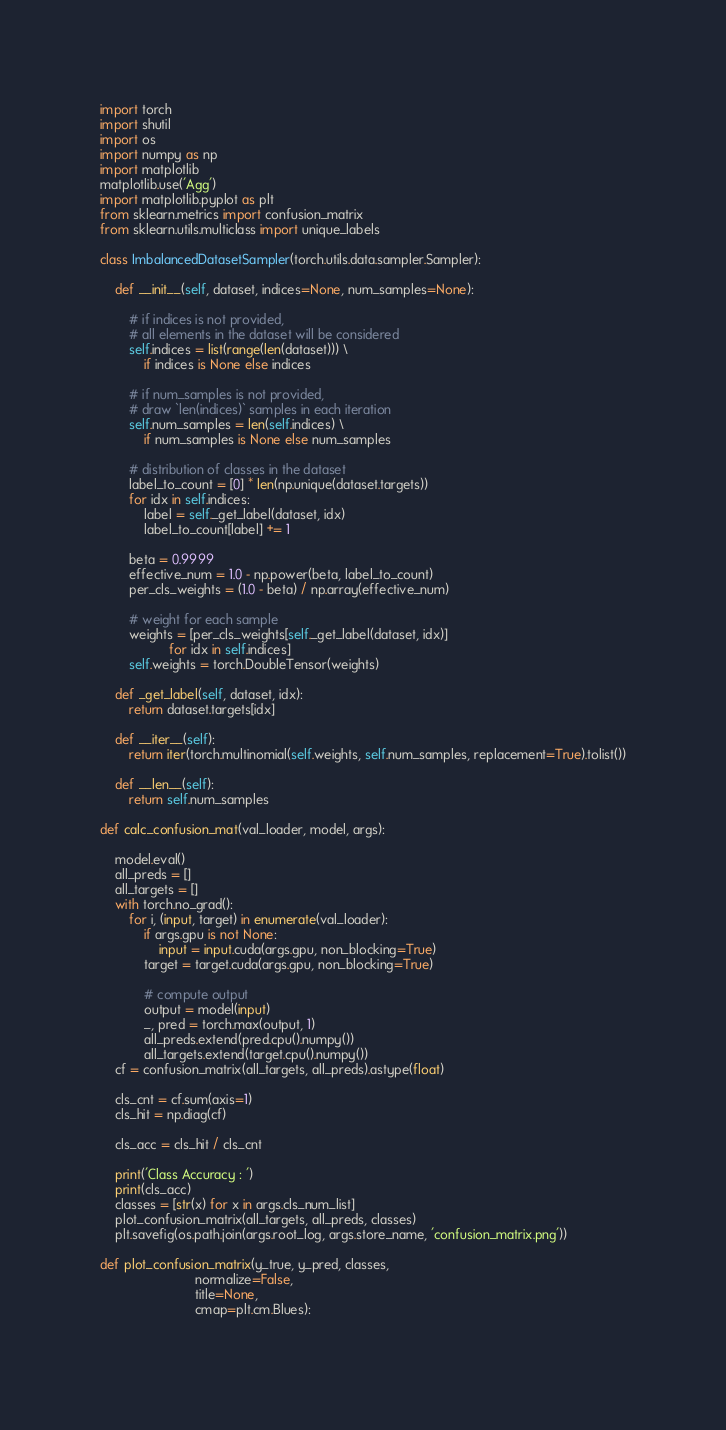<code> <loc_0><loc_0><loc_500><loc_500><_Python_>import torch
import shutil
import os
import numpy as np
import matplotlib
matplotlib.use('Agg')
import matplotlib.pyplot as plt
from sklearn.metrics import confusion_matrix
from sklearn.utils.multiclass import unique_labels

class ImbalancedDatasetSampler(torch.utils.data.sampler.Sampler):

    def __init__(self, dataset, indices=None, num_samples=None):
                
        # if indices is not provided, 
        # all elements in the dataset will be considered
        self.indices = list(range(len(dataset))) \
            if indices is None else indices
            
        # if num_samples is not provided, 
        # draw `len(indices)` samples in each iteration
        self.num_samples = len(self.indices) \
            if num_samples is None else num_samples
            
        # distribution of classes in the dataset 
        label_to_count = [0] * len(np.unique(dataset.targets))
        for idx in self.indices:
            label = self._get_label(dataset, idx)
            label_to_count[label] += 1
            
        beta = 0.9999
        effective_num = 1.0 - np.power(beta, label_to_count)
        per_cls_weights = (1.0 - beta) / np.array(effective_num)

        # weight for each sample
        weights = [per_cls_weights[self._get_label(dataset, idx)]
                   for idx in self.indices]
        self.weights = torch.DoubleTensor(weights)
        
    def _get_label(self, dataset, idx):
        return dataset.targets[idx]
                
    def __iter__(self):
        return iter(torch.multinomial(self.weights, self.num_samples, replacement=True).tolist())

    def __len__(self):
        return self.num_samples

def calc_confusion_mat(val_loader, model, args):
    
    model.eval()
    all_preds = []
    all_targets = []
    with torch.no_grad():
        for i, (input, target) in enumerate(val_loader):
            if args.gpu is not None:
                input = input.cuda(args.gpu, non_blocking=True)
            target = target.cuda(args.gpu, non_blocking=True)

            # compute output
            output = model(input)
            _, pred = torch.max(output, 1)
            all_preds.extend(pred.cpu().numpy())
            all_targets.extend(target.cpu().numpy())
    cf = confusion_matrix(all_targets, all_preds).astype(float)

    cls_cnt = cf.sum(axis=1)
    cls_hit = np.diag(cf)

    cls_acc = cls_hit / cls_cnt

    print('Class Accuracy : ')
    print(cls_acc)
    classes = [str(x) for x in args.cls_num_list]
    plot_confusion_matrix(all_targets, all_preds, classes)
    plt.savefig(os.path.join(args.root_log, args.store_name, 'confusion_matrix.png'))

def plot_confusion_matrix(y_true, y_pred, classes,
                          normalize=False,
                          title=None,
                          cmap=plt.cm.Blues):
    </code> 